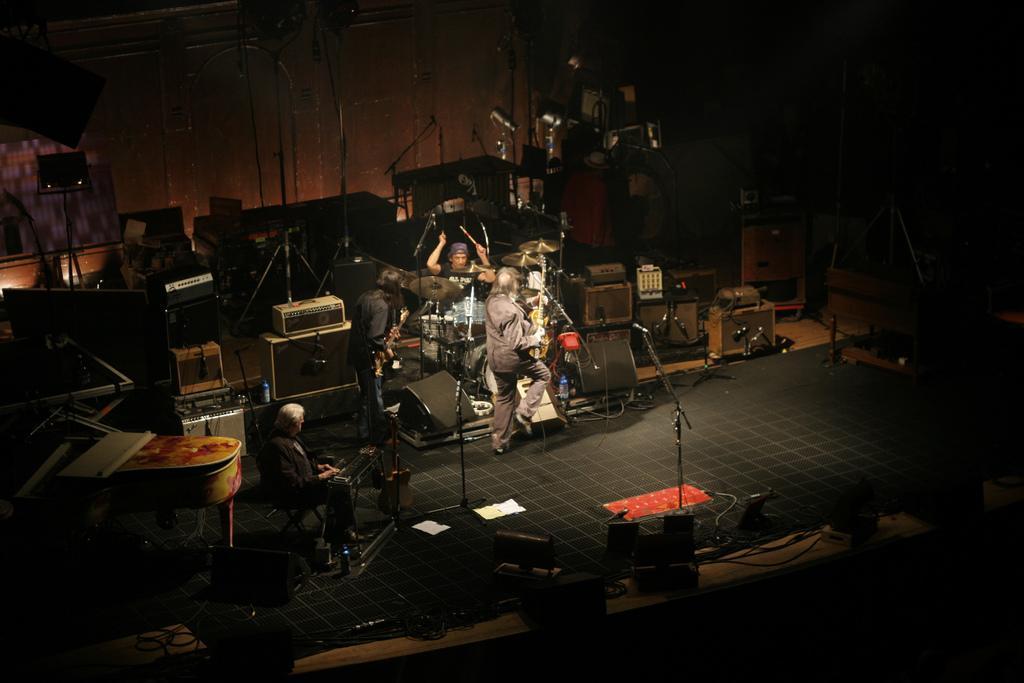In one or two sentences, can you explain what this image depicts? This is the man sitting on the chair and playing the piano. I can see two people standing and playing the guitars. Here is another person standing and playing the drums. These are the mics attached to the mike stands. I can see the electronic devices and few other objects, which are placed on the floor. This looks like another piano. These look like the stands. I can see the water bottles and papers on the floor. 